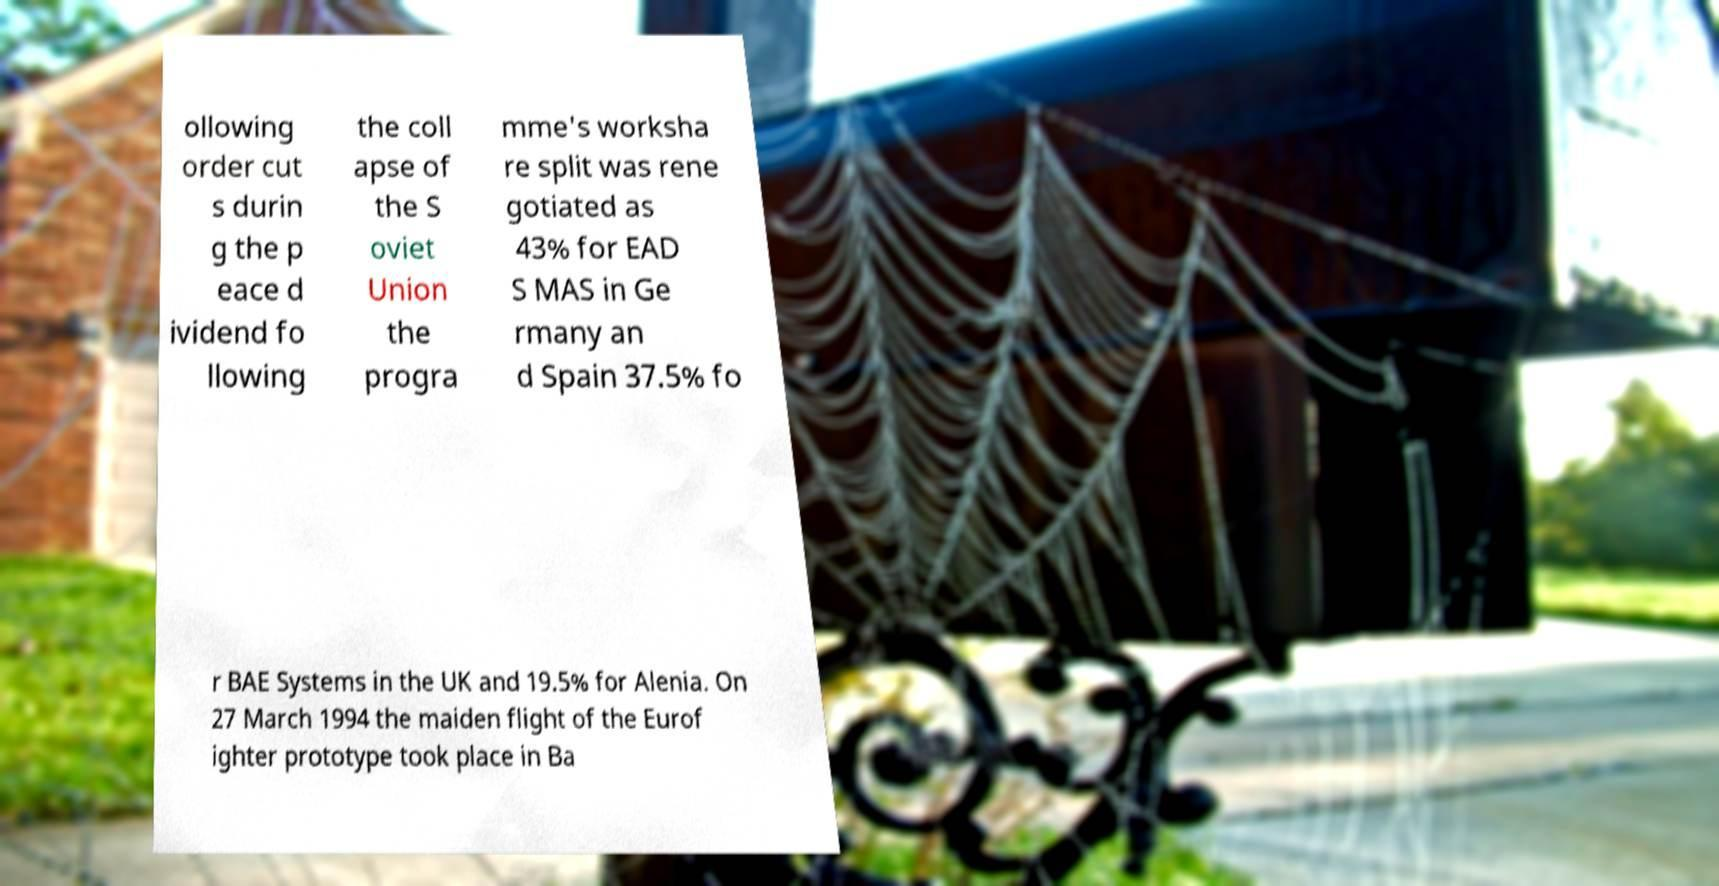Please identify and transcribe the text found in this image. ollowing order cut s durin g the p eace d ividend fo llowing the coll apse of the S oviet Union the progra mme's worksha re split was rene gotiated as 43% for EAD S MAS in Ge rmany an d Spain 37.5% fo r BAE Systems in the UK and 19.5% for Alenia. On 27 March 1994 the maiden flight of the Eurof ighter prototype took place in Ba 